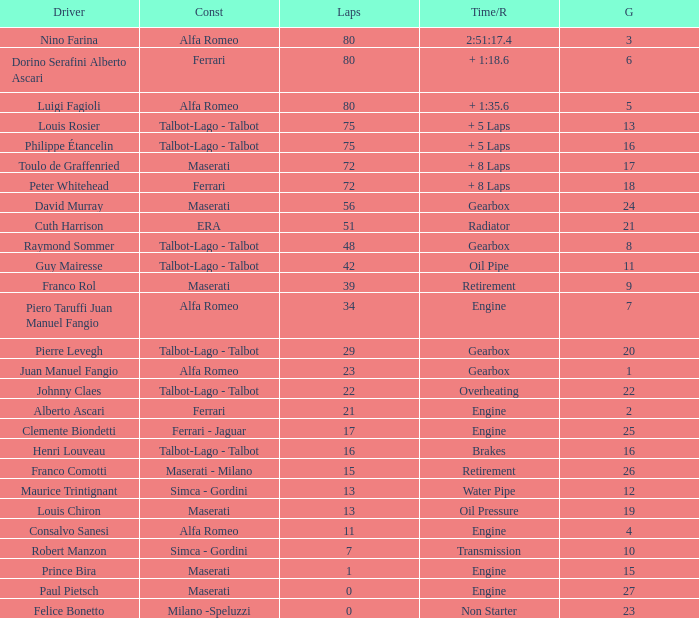What was the smallest grid for Prince bira? 15.0. 